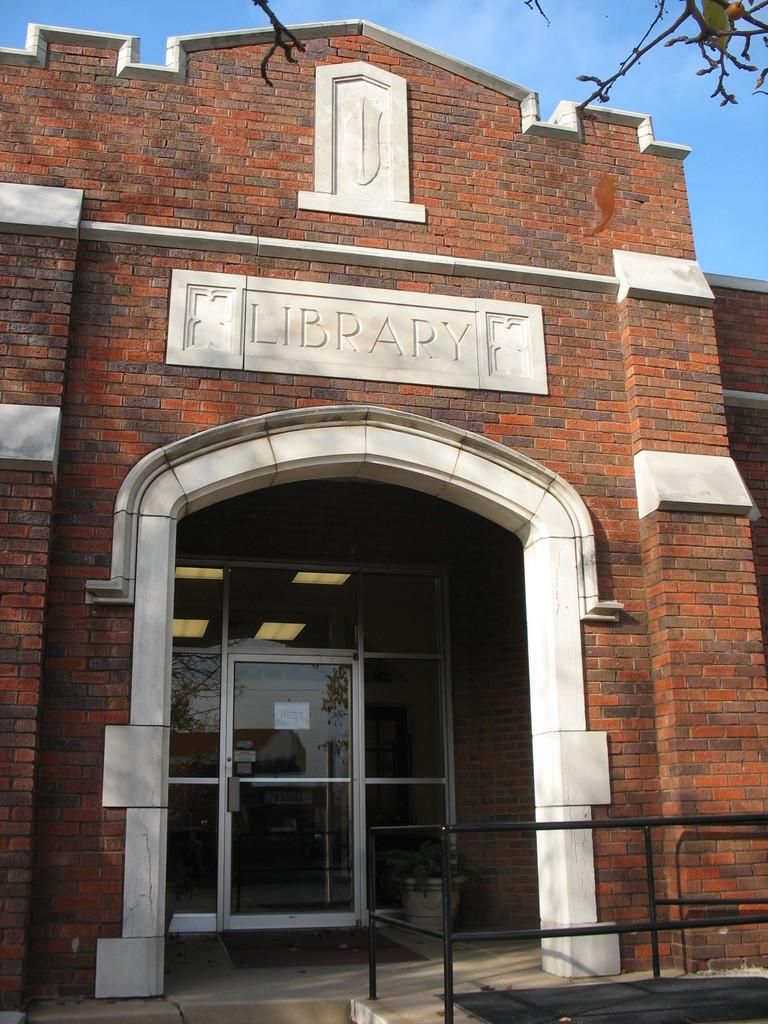Provide a one-sentence caption for the provided image. The brick and stone archway leading to a glass door entrance to a Library. 